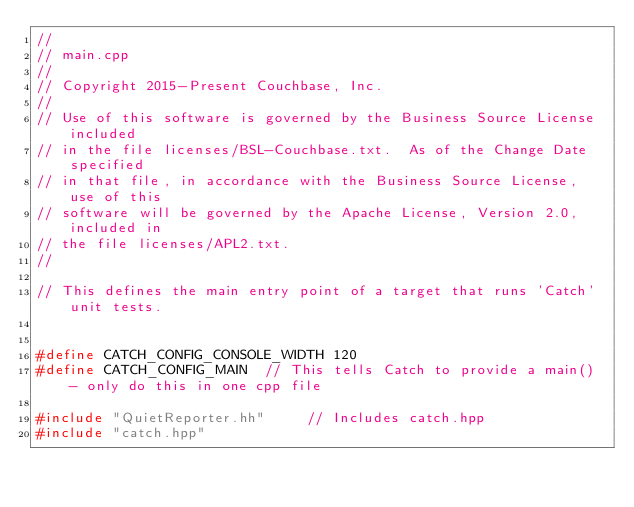<code> <loc_0><loc_0><loc_500><loc_500><_C++_>//
// main.cpp
//
// Copyright 2015-Present Couchbase, Inc.
//
// Use of this software is governed by the Business Source License included
// in the file licenses/BSL-Couchbase.txt.  As of the Change Date specified
// in that file, in accordance with the Business Source License, use of this
// software will be governed by the Apache License, Version 2.0, included in
// the file licenses/APL2.txt.
//

// This defines the main entry point of a target that runs 'Catch' unit tests.


#define CATCH_CONFIG_CONSOLE_WIDTH 120
#define CATCH_CONFIG_MAIN  // This tells Catch to provide a main() - only do this in one cpp file

#include "QuietReporter.hh"     // Includes catch.hpp
#include "catch.hpp"
</code> 